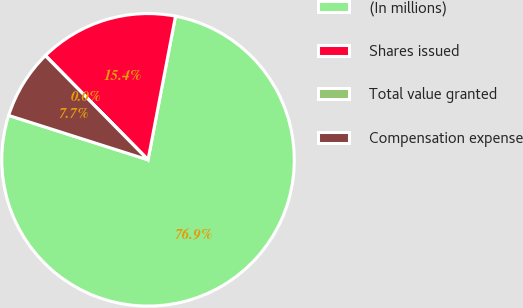Convert chart to OTSL. <chart><loc_0><loc_0><loc_500><loc_500><pie_chart><fcel>(In millions)<fcel>Shares issued<fcel>Total value granted<fcel>Compensation expense<nl><fcel>76.9%<fcel>15.39%<fcel>0.01%<fcel>7.7%<nl></chart> 